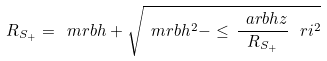Convert formula to latex. <formula><loc_0><loc_0><loc_500><loc_500>R _ { S _ { + } } = \ m r b h + \sqrt { \ m r b h ^ { 2 } - \leq \, \frac { \ a r b h z } { R _ { S _ { + } } } \, \ r i ^ { 2 } }</formula> 